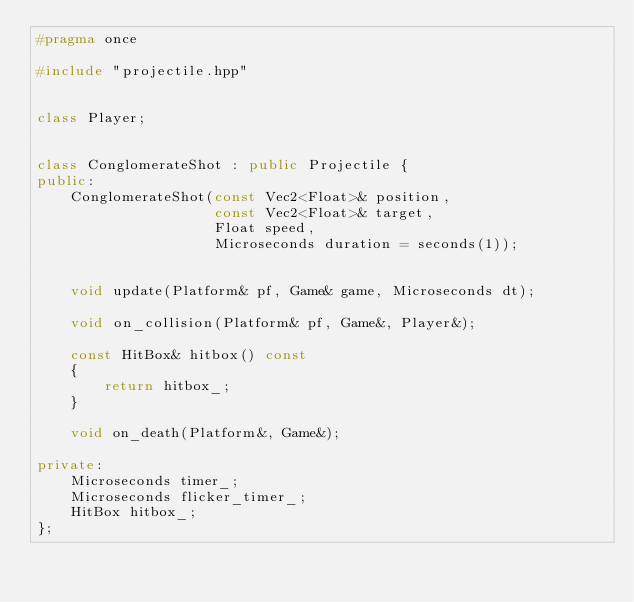<code> <loc_0><loc_0><loc_500><loc_500><_C++_>#pragma once

#include "projectile.hpp"


class Player;


class ConglomerateShot : public Projectile {
public:
    ConglomerateShot(const Vec2<Float>& position,
                     const Vec2<Float>& target,
                     Float speed,
                     Microseconds duration = seconds(1));


    void update(Platform& pf, Game& game, Microseconds dt);

    void on_collision(Platform& pf, Game&, Player&);

    const HitBox& hitbox() const
    {
        return hitbox_;
    }

    void on_death(Platform&, Game&);

private:
    Microseconds timer_;
    Microseconds flicker_timer_;
    HitBox hitbox_;
};
</code> 